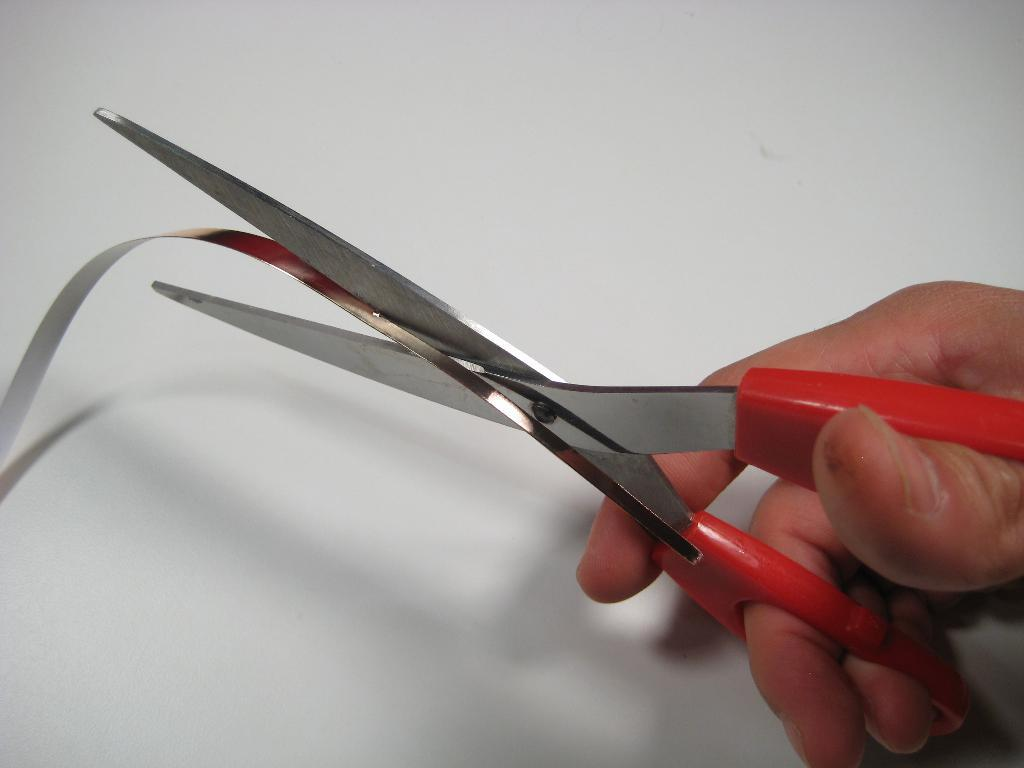What can be seen in the image related to a person's hand? There is a person's hand in the image. What is the hand holding? The hand is holding a scissor. What is the scissor being used for in the image? The scissor is cutting a metal strip. Can you tell me how many family members are talking in the image? There is no reference to family members or talking in the image; it features a person's hand holding a scissor that is cutting a metal strip. 